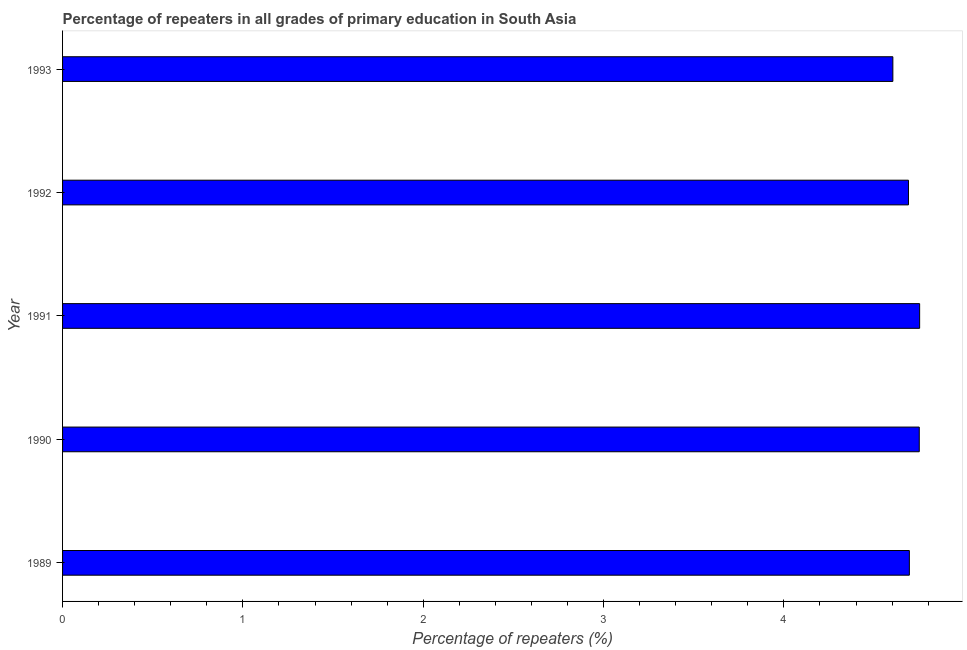What is the title of the graph?
Ensure brevity in your answer.  Percentage of repeaters in all grades of primary education in South Asia. What is the label or title of the X-axis?
Offer a terse response. Percentage of repeaters (%). What is the percentage of repeaters in primary education in 1991?
Give a very brief answer. 4.75. Across all years, what is the maximum percentage of repeaters in primary education?
Keep it short and to the point. 4.75. Across all years, what is the minimum percentage of repeaters in primary education?
Offer a very short reply. 4.6. In which year was the percentage of repeaters in primary education maximum?
Keep it short and to the point. 1991. What is the sum of the percentage of repeaters in primary education?
Offer a very short reply. 23.49. What is the difference between the percentage of repeaters in primary education in 1990 and 1991?
Ensure brevity in your answer.  -0. What is the average percentage of repeaters in primary education per year?
Make the answer very short. 4.7. What is the median percentage of repeaters in primary education?
Your response must be concise. 4.7. Do a majority of the years between 1990 and 1993 (inclusive) have percentage of repeaters in primary education greater than 1.6 %?
Your answer should be compact. Yes. What is the ratio of the percentage of repeaters in primary education in 1991 to that in 1992?
Make the answer very short. 1.01. Is the percentage of repeaters in primary education in 1989 less than that in 1993?
Provide a succinct answer. No. Is the difference between the percentage of repeaters in primary education in 1991 and 1993 greater than the difference between any two years?
Offer a very short reply. Yes. What is the difference between the highest and the second highest percentage of repeaters in primary education?
Offer a very short reply. 0. What is the difference between the highest and the lowest percentage of repeaters in primary education?
Ensure brevity in your answer.  0.15. In how many years, is the percentage of repeaters in primary education greater than the average percentage of repeaters in primary education taken over all years?
Your response must be concise. 2. How many years are there in the graph?
Keep it short and to the point. 5. Are the values on the major ticks of X-axis written in scientific E-notation?
Your response must be concise. No. What is the Percentage of repeaters (%) of 1989?
Provide a succinct answer. 4.7. What is the Percentage of repeaters (%) of 1990?
Ensure brevity in your answer.  4.75. What is the Percentage of repeaters (%) of 1991?
Provide a succinct answer. 4.75. What is the Percentage of repeaters (%) in 1992?
Provide a succinct answer. 4.69. What is the Percentage of repeaters (%) of 1993?
Offer a terse response. 4.6. What is the difference between the Percentage of repeaters (%) in 1989 and 1990?
Make the answer very short. -0.05. What is the difference between the Percentage of repeaters (%) in 1989 and 1991?
Your answer should be very brief. -0.06. What is the difference between the Percentage of repeaters (%) in 1989 and 1992?
Your response must be concise. 0. What is the difference between the Percentage of repeaters (%) in 1989 and 1993?
Your answer should be very brief. 0.09. What is the difference between the Percentage of repeaters (%) in 1990 and 1991?
Your answer should be very brief. -0. What is the difference between the Percentage of repeaters (%) in 1990 and 1992?
Your response must be concise. 0.06. What is the difference between the Percentage of repeaters (%) in 1990 and 1993?
Keep it short and to the point. 0.15. What is the difference between the Percentage of repeaters (%) in 1991 and 1992?
Your response must be concise. 0.06. What is the difference between the Percentage of repeaters (%) in 1991 and 1993?
Your response must be concise. 0.15. What is the difference between the Percentage of repeaters (%) in 1992 and 1993?
Your response must be concise. 0.09. What is the ratio of the Percentage of repeaters (%) in 1989 to that in 1990?
Offer a terse response. 0.99. What is the ratio of the Percentage of repeaters (%) in 1989 to that in 1992?
Ensure brevity in your answer.  1. What is the ratio of the Percentage of repeaters (%) in 1989 to that in 1993?
Keep it short and to the point. 1.02. What is the ratio of the Percentage of repeaters (%) in 1990 to that in 1993?
Provide a short and direct response. 1.03. What is the ratio of the Percentage of repeaters (%) in 1991 to that in 1992?
Offer a terse response. 1.01. What is the ratio of the Percentage of repeaters (%) in 1991 to that in 1993?
Give a very brief answer. 1.03. 